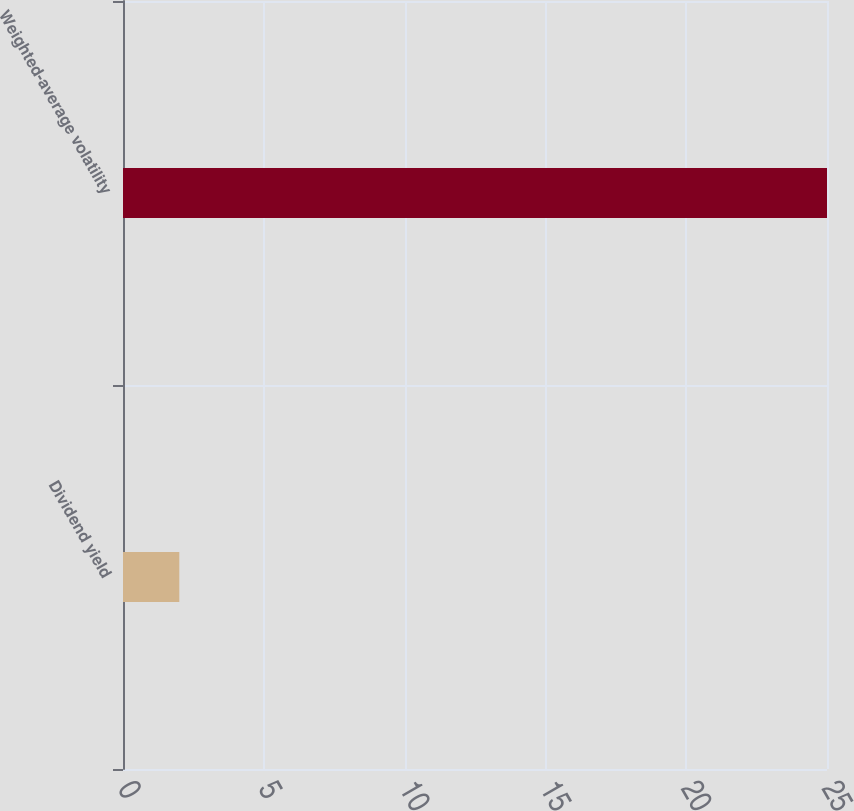Convert chart to OTSL. <chart><loc_0><loc_0><loc_500><loc_500><bar_chart><fcel>Dividend yield<fcel>Weighted-average volatility<nl><fcel>2<fcel>25<nl></chart> 